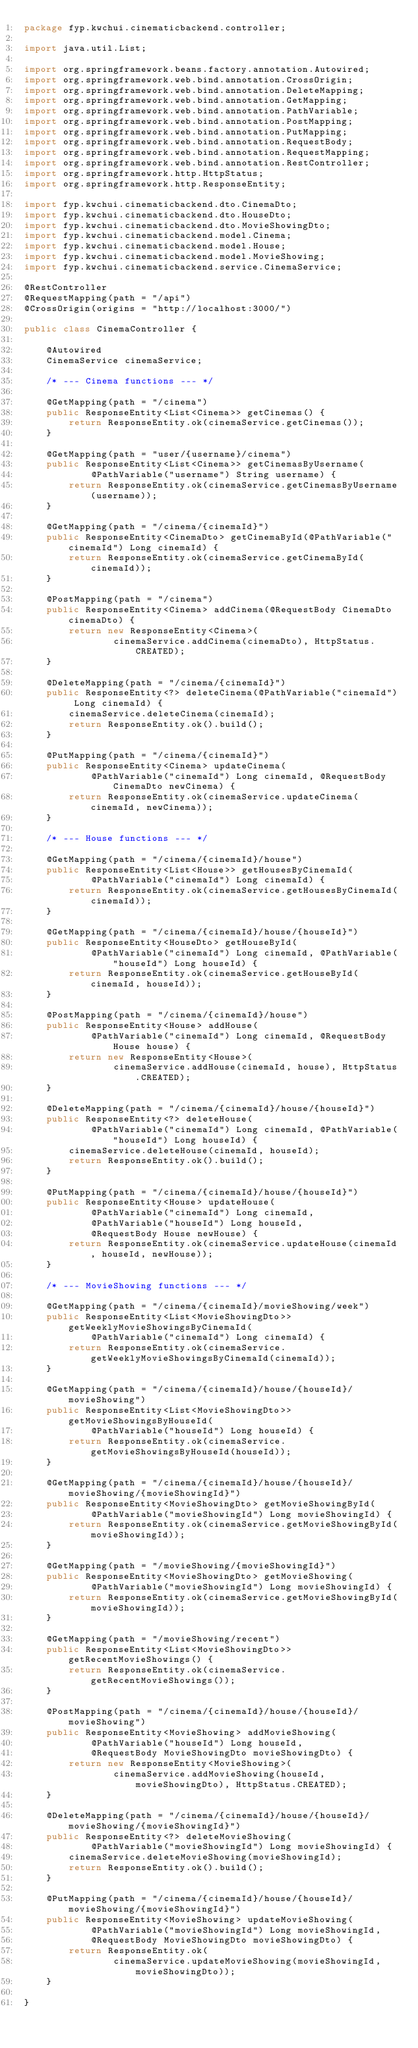Convert code to text. <code><loc_0><loc_0><loc_500><loc_500><_Java_>package fyp.kwchui.cinematicbackend.controller;

import java.util.List;

import org.springframework.beans.factory.annotation.Autowired;
import org.springframework.web.bind.annotation.CrossOrigin;
import org.springframework.web.bind.annotation.DeleteMapping;
import org.springframework.web.bind.annotation.GetMapping;
import org.springframework.web.bind.annotation.PathVariable;
import org.springframework.web.bind.annotation.PostMapping;
import org.springframework.web.bind.annotation.PutMapping;
import org.springframework.web.bind.annotation.RequestBody;
import org.springframework.web.bind.annotation.RequestMapping;
import org.springframework.web.bind.annotation.RestController;
import org.springframework.http.HttpStatus;
import org.springframework.http.ResponseEntity;

import fyp.kwchui.cinematicbackend.dto.CinemaDto;
import fyp.kwchui.cinematicbackend.dto.HouseDto;
import fyp.kwchui.cinematicbackend.dto.MovieShowingDto;
import fyp.kwchui.cinematicbackend.model.Cinema;
import fyp.kwchui.cinematicbackend.model.House;
import fyp.kwchui.cinematicbackend.model.MovieShowing;
import fyp.kwchui.cinematicbackend.service.CinemaService;

@RestController
@RequestMapping(path = "/api")
@CrossOrigin(origins = "http://localhost:3000/")

public class CinemaController {

    @Autowired
    CinemaService cinemaService;

    /* --- Cinema functions --- */

    @GetMapping(path = "/cinema")
    public ResponseEntity<List<Cinema>> getCinemas() {
        return ResponseEntity.ok(cinemaService.getCinemas());
    }

    @GetMapping(path = "user/{username}/cinema")
    public ResponseEntity<List<Cinema>> getCinemasByUsername(
            @PathVariable("username") String username) {
        return ResponseEntity.ok(cinemaService.getCinemasByUsername(username));
    }

    @GetMapping(path = "/cinema/{cinemaId}")
    public ResponseEntity<CinemaDto> getCinemaById(@PathVariable("cinemaId") Long cinemaId) {
        return ResponseEntity.ok(cinemaService.getCinemaById(cinemaId));
    }

    @PostMapping(path = "/cinema")
    public ResponseEntity<Cinema> addCinema(@RequestBody CinemaDto cinemaDto) {
        return new ResponseEntity<Cinema>(
                cinemaService.addCinema(cinemaDto), HttpStatus.CREATED);
    }

    @DeleteMapping(path = "/cinema/{cinemaId}")
    public ResponseEntity<?> deleteCinema(@PathVariable("cinemaId") Long cinemaId) {
        cinemaService.deleteCinema(cinemaId);
        return ResponseEntity.ok().build();
    }

    @PutMapping(path = "/cinema/{cinemaId}")
    public ResponseEntity<Cinema> updateCinema(
            @PathVariable("cinemaId") Long cinemaId, @RequestBody CinemaDto newCinema) {
        return ResponseEntity.ok(cinemaService.updateCinema(cinemaId, newCinema));
    }

    /* --- House functions --- */

    @GetMapping(path = "/cinema/{cinemaId}/house")
    public ResponseEntity<List<House>> getHousesByCinemaId(
            @PathVariable("cinemaId") Long cinemaId) {
        return ResponseEntity.ok(cinemaService.getHousesByCinemaId(cinemaId));
    }

    @GetMapping(path = "/cinema/{cinemaId}/house/{houseId}")
    public ResponseEntity<HouseDto> getHouseById(
            @PathVariable("cinemaId") Long cinemaId, @PathVariable("houseId") Long houseId) {
        return ResponseEntity.ok(cinemaService.getHouseById(cinemaId, houseId));
    }

    @PostMapping(path = "/cinema/{cinemaId}/house")
    public ResponseEntity<House> addHouse(
            @PathVariable("cinemaId") Long cinemaId, @RequestBody House house) {
        return new ResponseEntity<House>(
                cinemaService.addHouse(cinemaId, house), HttpStatus.CREATED);
    }

    @DeleteMapping(path = "/cinema/{cinemaId}/house/{houseId}")
    public ResponseEntity<?> deleteHouse(
            @PathVariable("cinemaId") Long cinemaId, @PathVariable("houseId") Long houseId) {
        cinemaService.deleteHouse(cinemaId, houseId);
        return ResponseEntity.ok().build();
    }

    @PutMapping(path = "/cinema/{cinemaId}/house/{houseId}")
    public ResponseEntity<House> updateHouse(
            @PathVariable("cinemaId") Long cinemaId,
            @PathVariable("houseId") Long houseId,
            @RequestBody House newHouse) {
        return ResponseEntity.ok(cinemaService.updateHouse(cinemaId, houseId, newHouse));
    }

    /* --- MovieShowing functions --- */

    @GetMapping(path = "/cinema/{cinemaId}/movieShowing/week")
    public ResponseEntity<List<MovieShowingDto>> getWeeklyMovieShowingsByCinemaId(
            @PathVariable("cinemaId") Long cinemaId) {
        return ResponseEntity.ok(cinemaService.getWeeklyMovieShowingsByCinemaId(cinemaId));
    }

    @GetMapping(path = "/cinema/{cinemaId}/house/{houseId}/movieShowing")
    public ResponseEntity<List<MovieShowingDto>> getMovieShowingsByHouseId(
            @PathVariable("houseId") Long houseId) {
        return ResponseEntity.ok(cinemaService.getMovieShowingsByHouseId(houseId));
    }

    @GetMapping(path = "/cinema/{cinemaId}/house/{houseId}/movieShowing/{movieShowingId}")
    public ResponseEntity<MovieShowingDto> getMovieShowingById(
            @PathVariable("movieShowingId") Long movieShowingId) {
        return ResponseEntity.ok(cinemaService.getMovieShowingById(movieShowingId));
    }

    @GetMapping(path = "/movieShowing/{movieShowingId}")
    public ResponseEntity<MovieShowingDto> getMovieShowing(
            @PathVariable("movieShowingId") Long movieShowingId) {
        return ResponseEntity.ok(cinemaService.getMovieShowingById(movieShowingId));
    }

    @GetMapping(path = "/movieShowing/recent")
    public ResponseEntity<List<MovieShowingDto>> getRecentMovieShowings() {
        return ResponseEntity.ok(cinemaService.getRecentMovieShowings());
    }

    @PostMapping(path = "/cinema/{cinemaId}/house/{houseId}/movieShowing")
    public ResponseEntity<MovieShowing> addMovieShowing(
            @PathVariable("houseId") Long houseId,
            @RequestBody MovieShowingDto movieShowingDto) {
        return new ResponseEntity<MovieShowing>(
                cinemaService.addMovieShowing(houseId, movieShowingDto), HttpStatus.CREATED);
    }

    @DeleteMapping(path = "/cinema/{cinemaId}/house/{houseId}/movieShowing/{movieShowingId}")
    public ResponseEntity<?> deleteMovieShowing(
            @PathVariable("movieShowingId") Long movieShowingId) {
        cinemaService.deleteMovieShowing(movieShowingId);
        return ResponseEntity.ok().build();
    }

    @PutMapping(path = "/cinema/{cinemaId}/house/{houseId}/movieShowing/{movieShowingId}")
    public ResponseEntity<MovieShowing> updateMovieShowing(
            @PathVariable("movieShowingId") Long movieShowingId,
            @RequestBody MovieShowingDto movieShowingDto) {
        return ResponseEntity.ok(
                cinemaService.updateMovieShowing(movieShowingId, movieShowingDto));
    }

}
</code> 